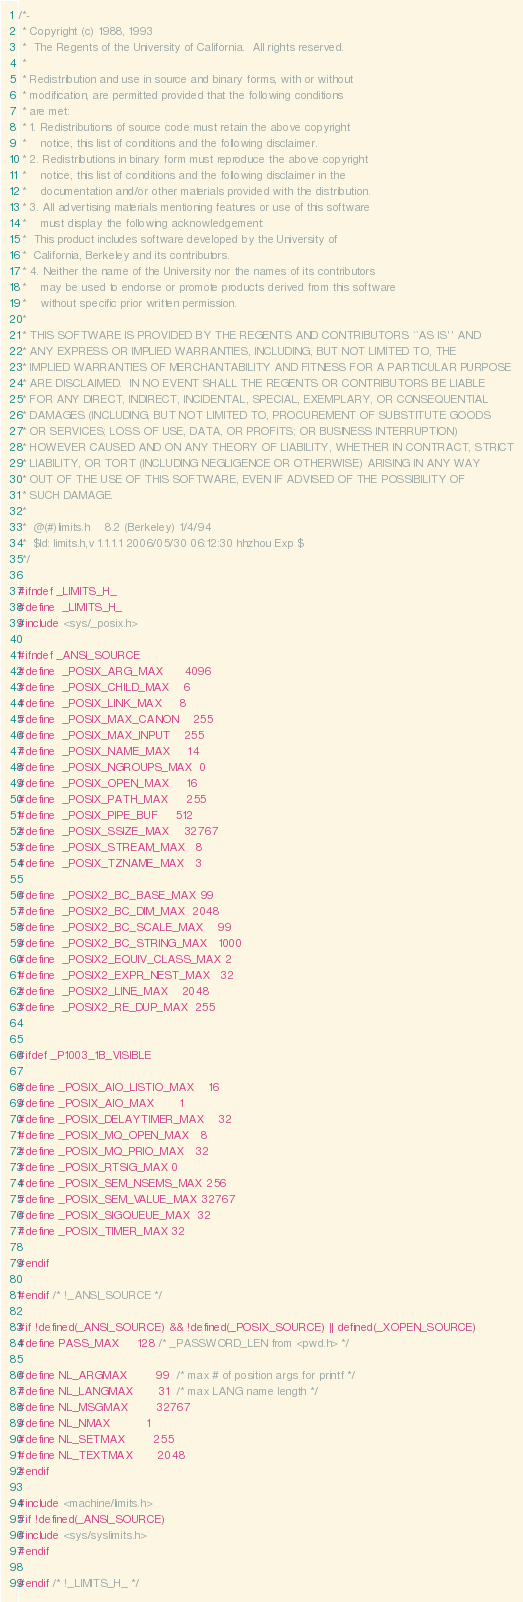<code> <loc_0><loc_0><loc_500><loc_500><_C_>/*-
 * Copyright (c) 1988, 1993
 *	The Regents of the University of California.  All rights reserved.
 *
 * Redistribution and use in source and binary forms, with or without
 * modification, are permitted provided that the following conditions
 * are met:
 * 1. Redistributions of source code must retain the above copyright
 *    notice, this list of conditions and the following disclaimer.
 * 2. Redistributions in binary form must reproduce the above copyright
 *    notice, this list of conditions and the following disclaimer in the
 *    documentation and/or other materials provided with the distribution.
 * 3. All advertising materials mentioning features or use of this software
 *    must display the following acknowledgement:
 *	This product includes software developed by the University of
 *	California, Berkeley and its contributors.
 * 4. Neither the name of the University nor the names of its contributors
 *    may be used to endorse or promote products derived from this software
 *    without specific prior written permission.
 *
 * THIS SOFTWARE IS PROVIDED BY THE REGENTS AND CONTRIBUTORS ``AS IS'' AND
 * ANY EXPRESS OR IMPLIED WARRANTIES, INCLUDING, BUT NOT LIMITED TO, THE
 * IMPLIED WARRANTIES OF MERCHANTABILITY AND FITNESS FOR A PARTICULAR PURPOSE
 * ARE DISCLAIMED.  IN NO EVENT SHALL THE REGENTS OR CONTRIBUTORS BE LIABLE
 * FOR ANY DIRECT, INDIRECT, INCIDENTAL, SPECIAL, EXEMPLARY, OR CONSEQUENTIAL
 * DAMAGES (INCLUDING, BUT NOT LIMITED TO, PROCUREMENT OF SUBSTITUTE GOODS
 * OR SERVICES; LOSS OF USE, DATA, OR PROFITS; OR BUSINESS INTERRUPTION)
 * HOWEVER CAUSED AND ON ANY THEORY OF LIABILITY, WHETHER IN CONTRACT, STRICT
 * LIABILITY, OR TORT (INCLUDING NEGLIGENCE OR OTHERWISE) ARISING IN ANY WAY
 * OUT OF THE USE OF THIS SOFTWARE, EVEN IF ADVISED OF THE POSSIBILITY OF
 * SUCH DAMAGE.
 *
 *	@(#)limits.h	8.2 (Berkeley) 1/4/94
 *	$Id: limits.h,v 1.1.1.1 2006/05/30 06:12:30 hhzhou Exp $
 */

#ifndef _LIMITS_H_
#define	_LIMITS_H_
#include <sys/_posix.h>

#ifndef _ANSI_SOURCE
#define	_POSIX_ARG_MAX		4096
#define	_POSIX_CHILD_MAX	6
#define	_POSIX_LINK_MAX		8
#define	_POSIX_MAX_CANON	255
#define	_POSIX_MAX_INPUT	255
#define	_POSIX_NAME_MAX		14
#define	_POSIX_NGROUPS_MAX	0
#define	_POSIX_OPEN_MAX		16
#define	_POSIX_PATH_MAX		255
#define	_POSIX_PIPE_BUF		512
#define	_POSIX_SSIZE_MAX	32767
#define	_POSIX_STREAM_MAX	8
#define	_POSIX_TZNAME_MAX	3

#define	_POSIX2_BC_BASE_MAX	99
#define	_POSIX2_BC_DIM_MAX	2048
#define	_POSIX2_BC_SCALE_MAX	99
#define	_POSIX2_BC_STRING_MAX	1000
#define	_POSIX2_EQUIV_CLASS_MAX	2
#define	_POSIX2_EXPR_NEST_MAX	32
#define	_POSIX2_LINE_MAX	2048
#define	_POSIX2_RE_DUP_MAX	255


#ifdef _P1003_1B_VISIBLE

#define _POSIX_AIO_LISTIO_MAX	16
#define _POSIX_AIO_MAX		1
#define _POSIX_DELAYTIMER_MAX	32
#define _POSIX_MQ_OPEN_MAX	8
#define _POSIX_MQ_PRIO_MAX	32
#define _POSIX_RTSIG_MAX	0
#define _POSIX_SEM_NSEMS_MAX	256
#define _POSIX_SEM_VALUE_MAX	32767
#define _POSIX_SIGQUEUE_MAX	32
#define _POSIX_TIMER_MAX	32

#endif

#endif /* !_ANSI_SOURCE */

#if !defined(_ANSI_SOURCE) && !defined(_POSIX_SOURCE) || defined(_XOPEN_SOURCE)
#define PASS_MAX		128	/* _PASSWORD_LEN from <pwd.h> */

#define NL_ARGMAX		99	/* max # of position args for printf */
#define NL_LANGMAX		31	/* max LANG name length */
#define NL_MSGMAX		32767
#define NL_NMAX			1
#define NL_SETMAX		255
#define NL_TEXTMAX		2048
#endif 

#include <machine/limits.h>
#if !defined(_ANSI_SOURCE)
#include <sys/syslimits.h>
#endif

#endif /* !_LIMITS_H_ */
</code> 